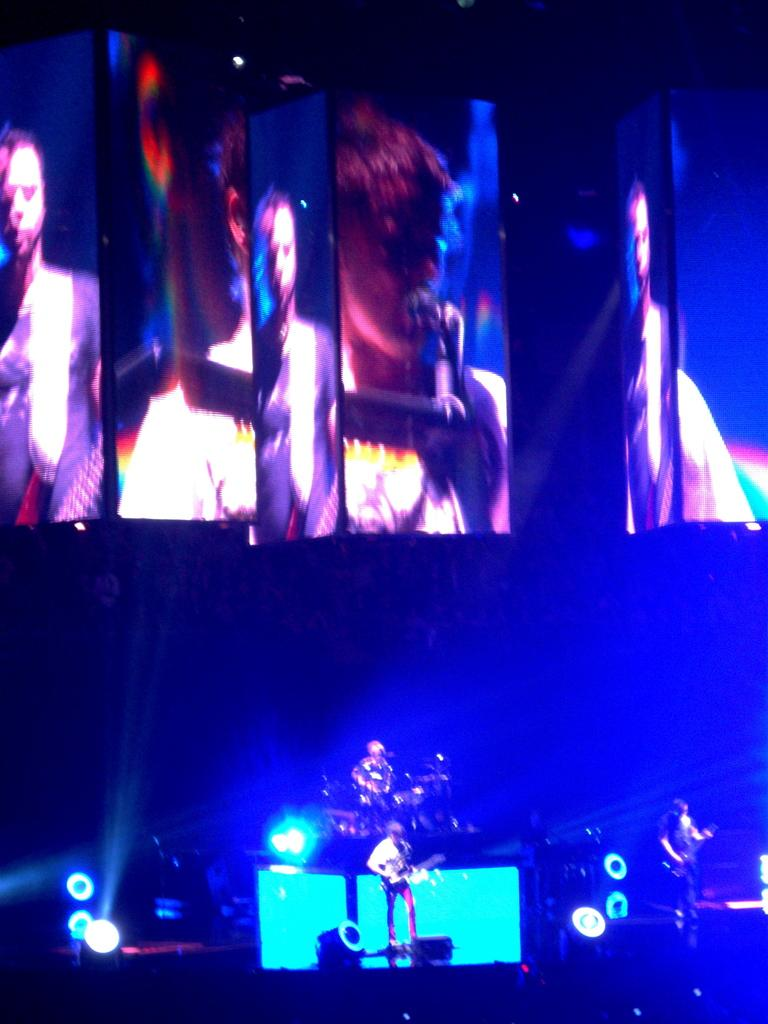Who or what is the main subject in the center of the image? There is a person in the center of the image. What type of lighting is present at the bottom side of the image? There are spotlights at the bottom side of the image. What kind of display devices are located at the top side of the image? There are screens at the top side of the image. What type of music can be heard playing in the background of the image? There is no music present in the image, as it only shows a person, spotlights, and screens. 